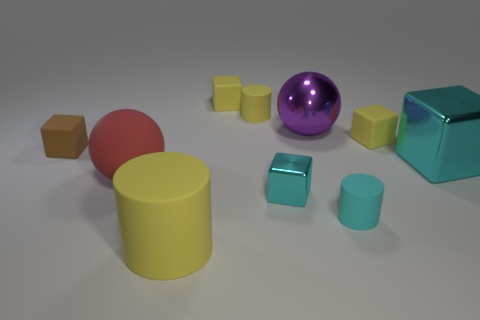What materials do the objects appear to be made of? The objects in the image exhibit a variety of textures that imply different materials. The shiny purple sphere has a reflective metallic surface, while the teal cube appears to have a smooth, possibly plastic finish. The yellow cylinder and the other objects have matt textures that might suggest rubber or a similar non-reflective material. 